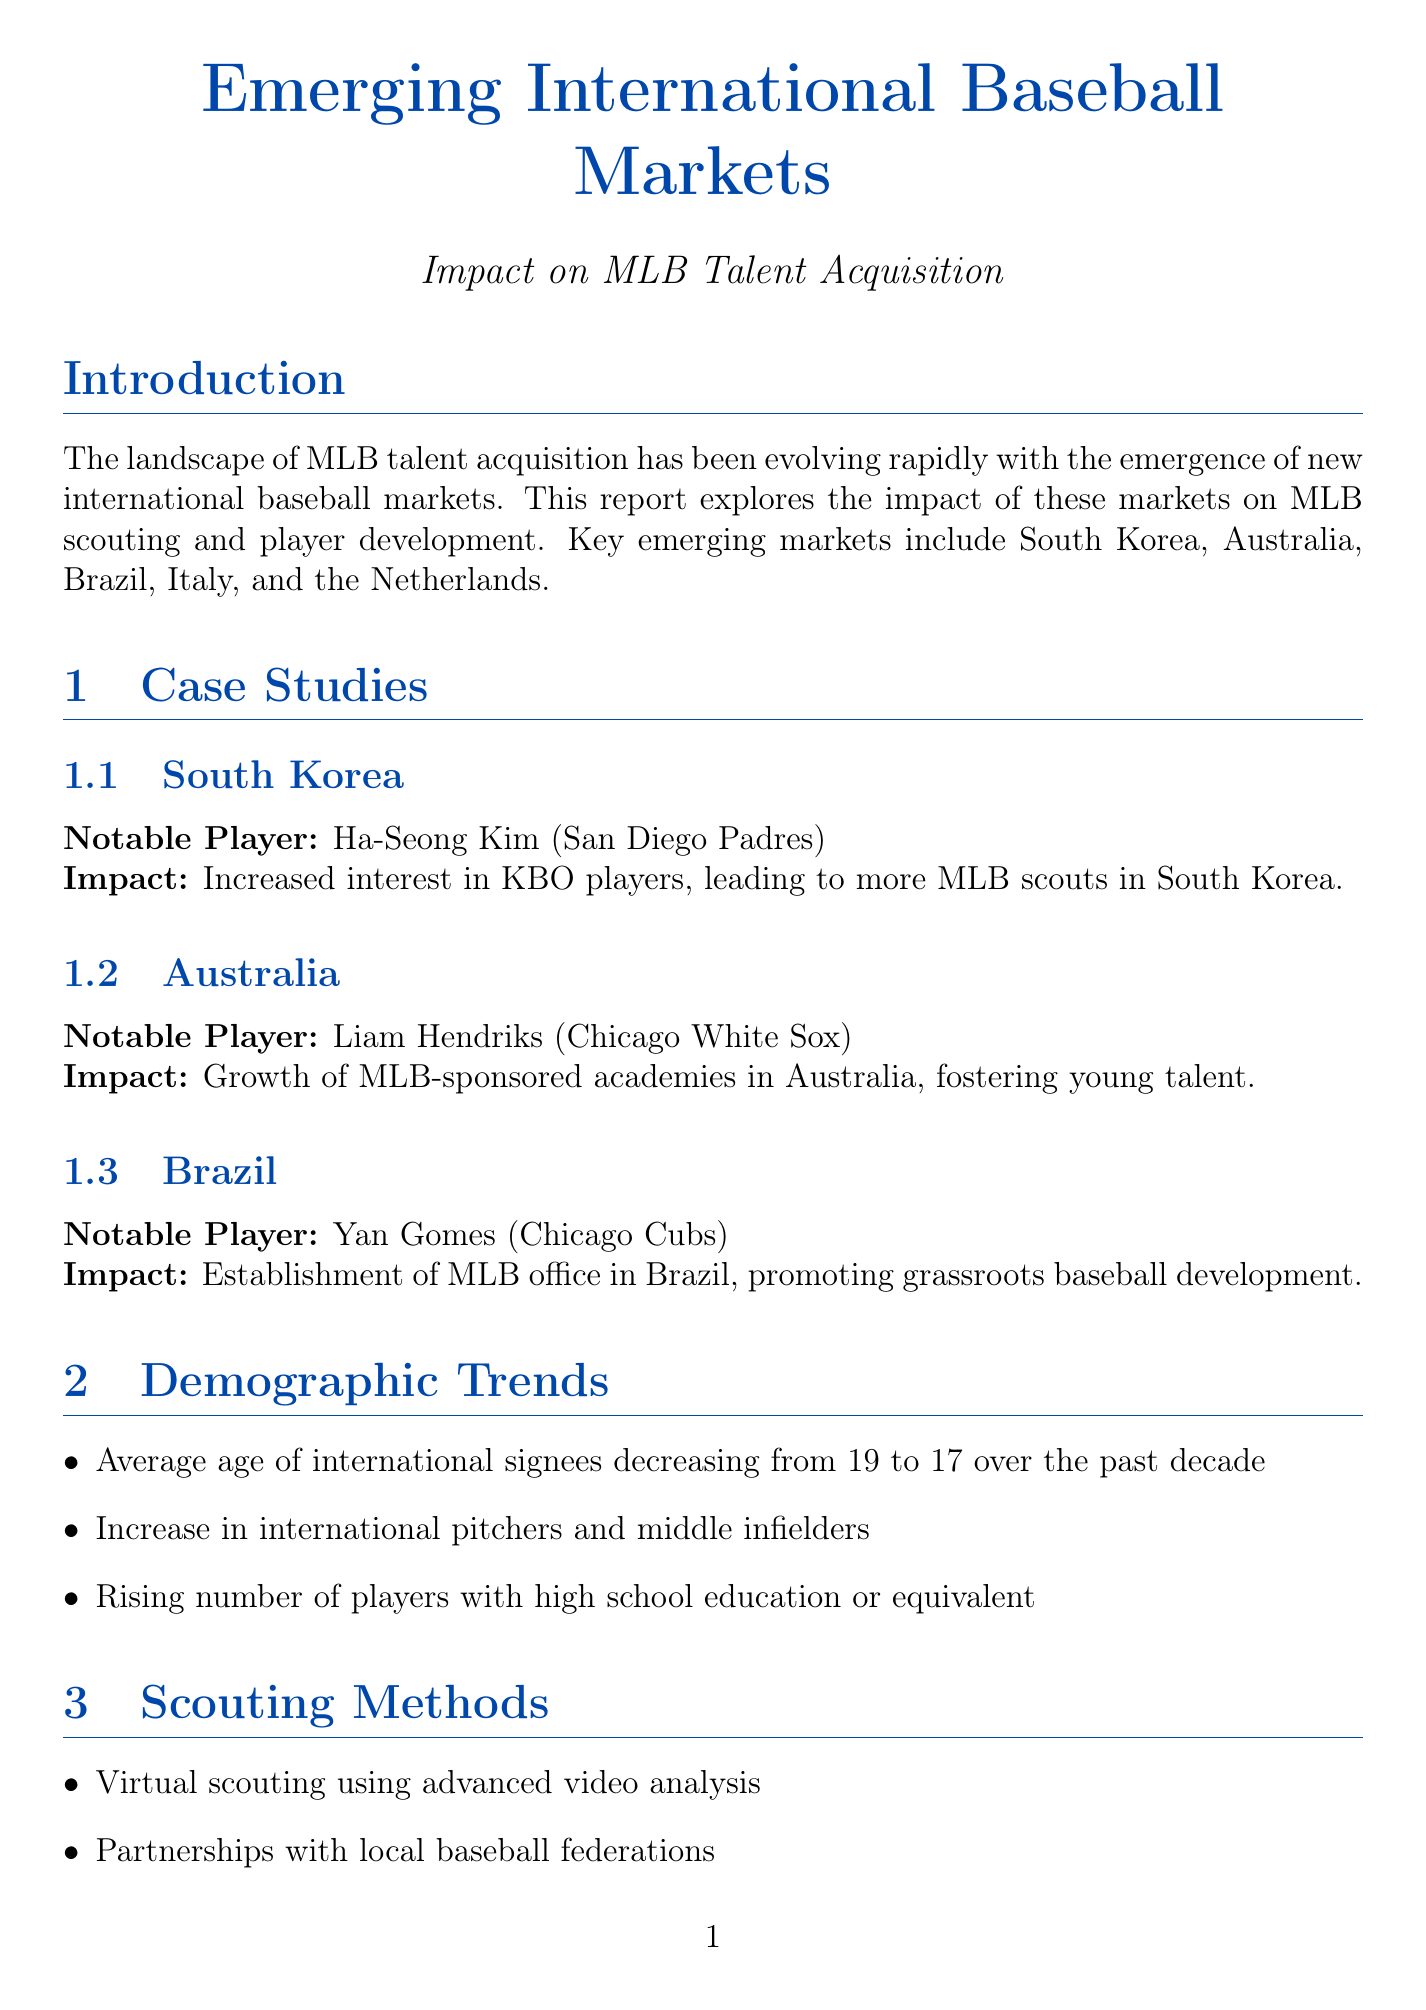what are the key emerging markets? The report highlights five key emerging markets that are shaping MLB talent acquisition: South Korea, Australia, Brazil, Italy, and the Netherlands.
Answer: South Korea, Australia, Brazil, Italy, Netherlands who is the notable player from Brazil? The report provides a case study of a notable player from Brazil, identifying him and his team. Yan Gomes is noted as the player from the Chicago Cubs.
Answer: Yan Gomes how has the average age of international signees changed? The report states that there has been a decrease in the average age of international signees from 19 to 17 over the last decade.
Answer: 17 what scouting method is mentioned for talent identification? One of the scouting methods mentioned includes virtual scouting using advanced video analysis, which is a modern approach to identifying talent.
Answer: Virtual scouting using advanced video analysis what challenges are faced by MLB in emerging markets? The report outlines several challenges related to cultural adaptation for young international players, emphasizing the difficulties in player development.
Answer: Cultural adaptation for young international players what is the future outlook for MLB talent acquisition? The conclusion of the report suggests a future outlook characterized by continued growth in international scouting and development efforts by MLB teams.
Answer: Continued growth in international scouting and development efforts by MLB teams which country is associated with the establishment of MLB office for grassroots development? The report specifically mentions Brazil regarding the establishment of an MLB office aimed at promoting grassroots baseball development.
Answer: Brazil what technological advancement is being utilized for talent identification? The report refers to the use of AI and machine learning as a technological advancement in talent identification within the international scouting landscape.
Answer: AI and machine learning 